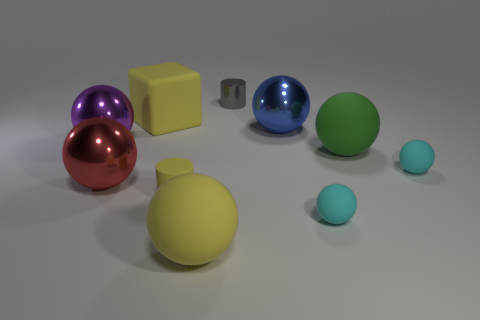Subtract all purple spheres. How many spheres are left? 6 Subtract all big red spheres. How many spheres are left? 6 Subtract all purple balls. Subtract all red cylinders. How many balls are left? 6 Subtract all spheres. How many objects are left? 3 Subtract 1 yellow cylinders. How many objects are left? 9 Subtract all red metallic spheres. Subtract all big yellow rubber balls. How many objects are left? 8 Add 1 big things. How many big things are left? 7 Add 2 tiny things. How many tiny things exist? 6 